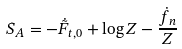Convert formula to latex. <formula><loc_0><loc_0><loc_500><loc_500>S _ { A } = - \dot { \tilde { F } } _ { t , 0 } + \log Z - \frac { \dot { f } _ { n } } Z</formula> 